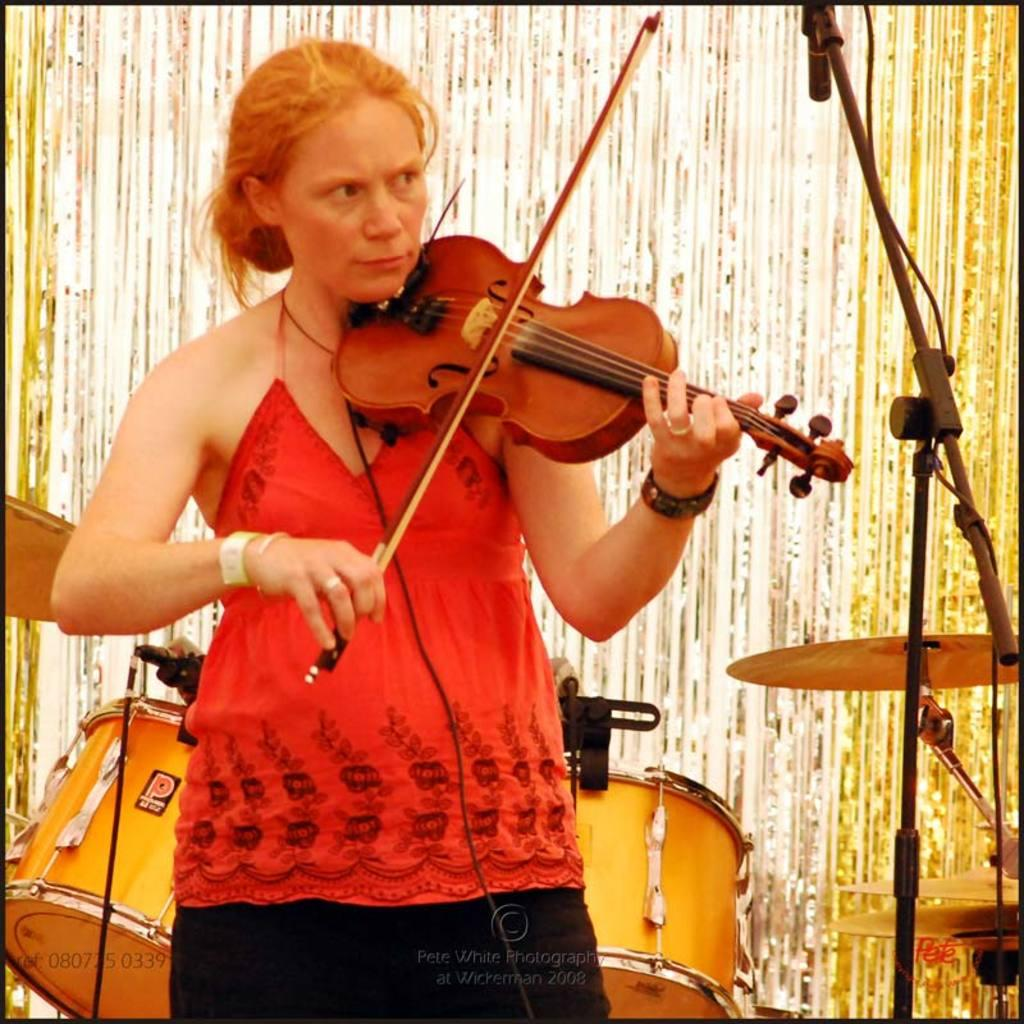Who is the main subject in the image? There is a lady standing in the center of the image. What is the lady doing in the image? The lady is playing a violin. What is in front of the lady? There is a stand before the lady. What can be seen in the background of the image? There is a band in the background of the image. Where is the pocket located on the trousers in the image? There are no trousers or pockets present in the image. What type of show is the lady performing in the image? The image does not provide information about the type of show or performance the lady is participating in. 